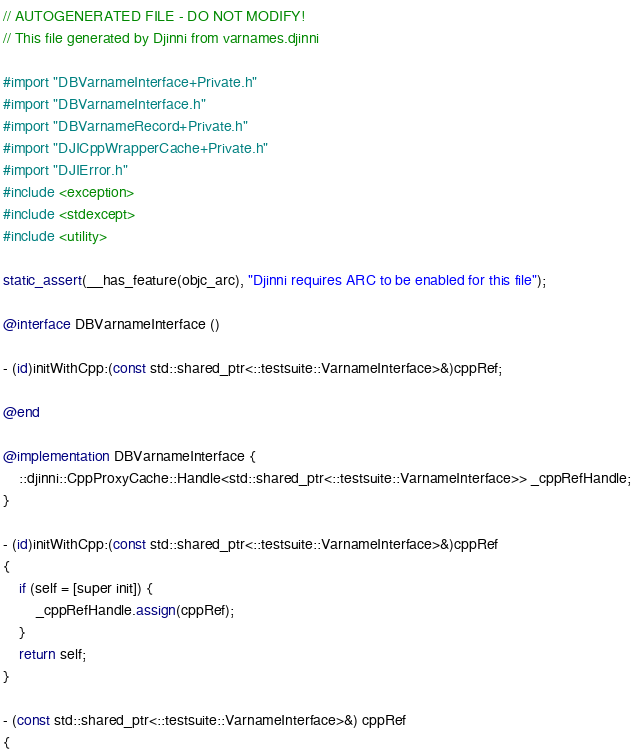Convert code to text. <code><loc_0><loc_0><loc_500><loc_500><_ObjectiveC_>// AUTOGENERATED FILE - DO NOT MODIFY!
// This file generated by Djinni from varnames.djinni

#import "DBVarnameInterface+Private.h"
#import "DBVarnameInterface.h"
#import "DBVarnameRecord+Private.h"
#import "DJICppWrapperCache+Private.h"
#import "DJIError.h"
#include <exception>
#include <stdexcept>
#include <utility>

static_assert(__has_feature(objc_arc), "Djinni requires ARC to be enabled for this file");

@interface DBVarnameInterface ()

- (id)initWithCpp:(const std::shared_ptr<::testsuite::VarnameInterface>&)cppRef;

@end

@implementation DBVarnameInterface {
    ::djinni::CppProxyCache::Handle<std::shared_ptr<::testsuite::VarnameInterface>> _cppRefHandle;
}

- (id)initWithCpp:(const std::shared_ptr<::testsuite::VarnameInterface>&)cppRef
{
    if (self = [super init]) {
        _cppRefHandle.assign(cppRef);
    }
    return self;
}

- (const std::shared_ptr<::testsuite::VarnameInterface>&) cppRef
{</code> 